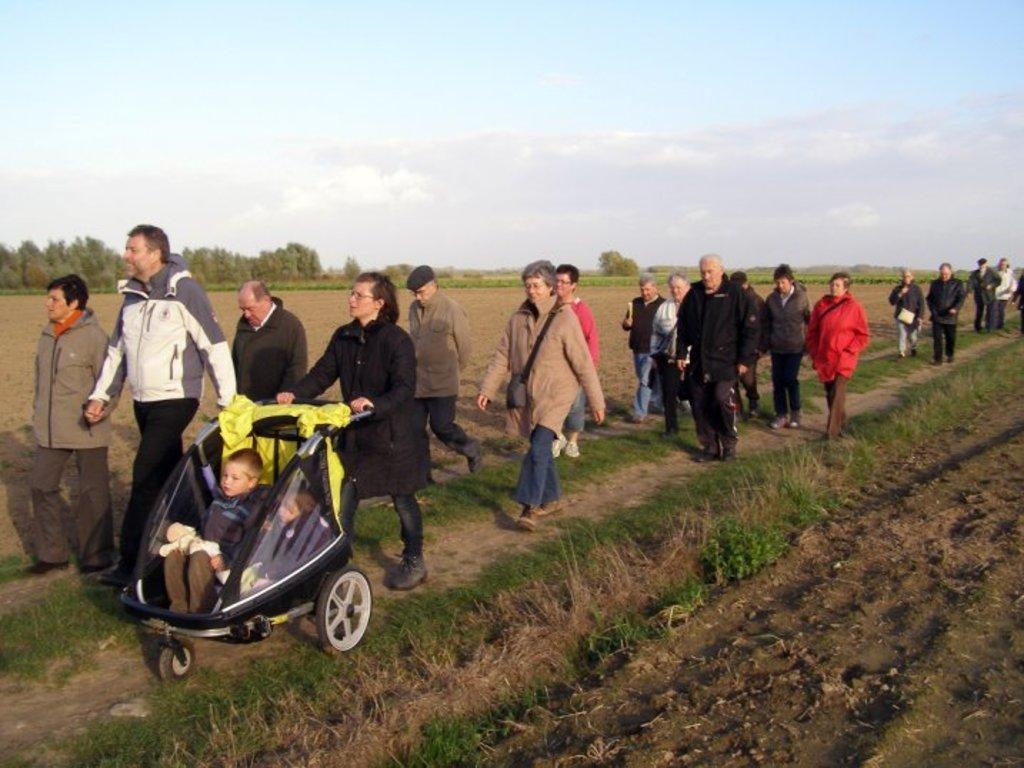Describe this image in one or two sentences. In this picture, we can see some people and we can see the ground with grass and we can see some trees, plants and the sky with clouds. 